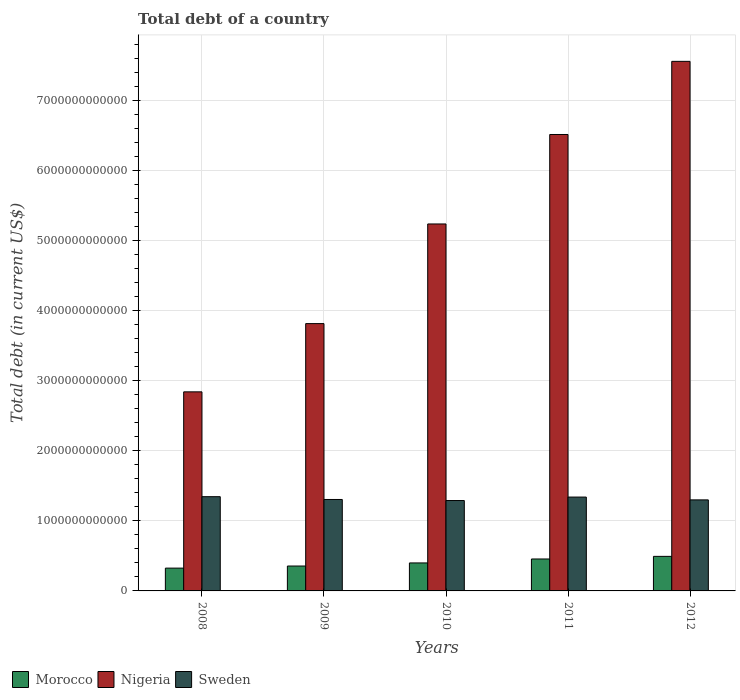How many different coloured bars are there?
Keep it short and to the point. 3. Are the number of bars per tick equal to the number of legend labels?
Provide a short and direct response. Yes. Are the number of bars on each tick of the X-axis equal?
Keep it short and to the point. Yes. In how many cases, is the number of bars for a given year not equal to the number of legend labels?
Keep it short and to the point. 0. What is the debt in Sweden in 2008?
Your answer should be very brief. 1.35e+12. Across all years, what is the maximum debt in Nigeria?
Keep it short and to the point. 7.56e+12. Across all years, what is the minimum debt in Sweden?
Give a very brief answer. 1.29e+12. In which year was the debt in Morocco minimum?
Ensure brevity in your answer.  2008. What is the total debt in Nigeria in the graph?
Offer a terse response. 2.60e+13. What is the difference between the debt in Sweden in 2008 and that in 2012?
Provide a succinct answer. 4.57e+1. What is the difference between the debt in Nigeria in 2008 and the debt in Morocco in 2009?
Provide a succinct answer. 2.49e+12. What is the average debt in Sweden per year?
Your response must be concise. 1.32e+12. In the year 2012, what is the difference between the debt in Morocco and debt in Nigeria?
Offer a terse response. -7.07e+12. What is the ratio of the debt in Nigeria in 2009 to that in 2010?
Your response must be concise. 0.73. Is the debt in Nigeria in 2008 less than that in 2011?
Give a very brief answer. Yes. Is the difference between the debt in Morocco in 2009 and 2012 greater than the difference between the debt in Nigeria in 2009 and 2012?
Give a very brief answer. Yes. What is the difference between the highest and the second highest debt in Morocco?
Keep it short and to the point. 3.75e+1. What is the difference between the highest and the lowest debt in Nigeria?
Offer a very short reply. 4.72e+12. What does the 2nd bar from the left in 2012 represents?
Your answer should be very brief. Nigeria. What does the 3rd bar from the right in 2012 represents?
Provide a succinct answer. Morocco. How many bars are there?
Provide a short and direct response. 15. Are all the bars in the graph horizontal?
Offer a terse response. No. How many years are there in the graph?
Provide a succinct answer. 5. What is the difference between two consecutive major ticks on the Y-axis?
Provide a succinct answer. 1.00e+12. Are the values on the major ticks of Y-axis written in scientific E-notation?
Provide a short and direct response. No. Does the graph contain grids?
Keep it short and to the point. Yes. How many legend labels are there?
Your answer should be compact. 3. How are the legend labels stacked?
Your response must be concise. Horizontal. What is the title of the graph?
Your response must be concise. Total debt of a country. Does "Zambia" appear as one of the legend labels in the graph?
Give a very brief answer. No. What is the label or title of the X-axis?
Offer a very short reply. Years. What is the label or title of the Y-axis?
Give a very brief answer. Total debt (in current US$). What is the Total debt (in current US$) in Morocco in 2008?
Your answer should be compact. 3.26e+11. What is the Total debt (in current US$) in Nigeria in 2008?
Ensure brevity in your answer.  2.84e+12. What is the Total debt (in current US$) of Sweden in 2008?
Keep it short and to the point. 1.35e+12. What is the Total debt (in current US$) in Morocco in 2009?
Offer a very short reply. 3.56e+11. What is the Total debt (in current US$) of Nigeria in 2009?
Your response must be concise. 3.82e+12. What is the Total debt (in current US$) of Sweden in 2009?
Your response must be concise. 1.31e+12. What is the Total debt (in current US$) of Morocco in 2010?
Your response must be concise. 4.00e+11. What is the Total debt (in current US$) of Nigeria in 2010?
Make the answer very short. 5.24e+12. What is the Total debt (in current US$) of Sweden in 2010?
Provide a short and direct response. 1.29e+12. What is the Total debt (in current US$) in Morocco in 2011?
Provide a succinct answer. 4.56e+11. What is the Total debt (in current US$) of Nigeria in 2011?
Your answer should be compact. 6.52e+12. What is the Total debt (in current US$) of Sweden in 2011?
Keep it short and to the point. 1.34e+12. What is the Total debt (in current US$) in Morocco in 2012?
Your answer should be compact. 4.94e+11. What is the Total debt (in current US$) in Nigeria in 2012?
Ensure brevity in your answer.  7.56e+12. What is the Total debt (in current US$) in Sweden in 2012?
Ensure brevity in your answer.  1.30e+12. Across all years, what is the maximum Total debt (in current US$) in Morocco?
Keep it short and to the point. 4.94e+11. Across all years, what is the maximum Total debt (in current US$) of Nigeria?
Ensure brevity in your answer.  7.56e+12. Across all years, what is the maximum Total debt (in current US$) in Sweden?
Give a very brief answer. 1.35e+12. Across all years, what is the minimum Total debt (in current US$) in Morocco?
Offer a very short reply. 3.26e+11. Across all years, what is the minimum Total debt (in current US$) in Nigeria?
Provide a short and direct response. 2.84e+12. Across all years, what is the minimum Total debt (in current US$) of Sweden?
Give a very brief answer. 1.29e+12. What is the total Total debt (in current US$) in Morocco in the graph?
Your answer should be very brief. 2.03e+12. What is the total Total debt (in current US$) in Nigeria in the graph?
Provide a succinct answer. 2.60e+13. What is the total Total debt (in current US$) in Sweden in the graph?
Make the answer very short. 6.58e+12. What is the difference between the Total debt (in current US$) of Morocco in 2008 and that in 2009?
Provide a short and direct response. -2.98e+1. What is the difference between the Total debt (in current US$) in Nigeria in 2008 and that in 2009?
Give a very brief answer. -9.75e+11. What is the difference between the Total debt (in current US$) in Sweden in 2008 and that in 2009?
Your response must be concise. 3.99e+1. What is the difference between the Total debt (in current US$) of Morocco in 2008 and that in 2010?
Your answer should be very brief. -7.41e+1. What is the difference between the Total debt (in current US$) in Nigeria in 2008 and that in 2010?
Your answer should be compact. -2.40e+12. What is the difference between the Total debt (in current US$) of Sweden in 2008 and that in 2010?
Offer a terse response. 5.51e+1. What is the difference between the Total debt (in current US$) of Morocco in 2008 and that in 2011?
Provide a short and direct response. -1.30e+11. What is the difference between the Total debt (in current US$) of Nigeria in 2008 and that in 2011?
Your answer should be very brief. -3.68e+12. What is the difference between the Total debt (in current US$) in Sweden in 2008 and that in 2011?
Keep it short and to the point. 5.63e+09. What is the difference between the Total debt (in current US$) in Morocco in 2008 and that in 2012?
Offer a terse response. -1.68e+11. What is the difference between the Total debt (in current US$) in Nigeria in 2008 and that in 2012?
Make the answer very short. -4.72e+12. What is the difference between the Total debt (in current US$) in Sweden in 2008 and that in 2012?
Provide a succinct answer. 4.57e+1. What is the difference between the Total debt (in current US$) in Morocco in 2009 and that in 2010?
Provide a short and direct response. -4.43e+1. What is the difference between the Total debt (in current US$) of Nigeria in 2009 and that in 2010?
Offer a terse response. -1.42e+12. What is the difference between the Total debt (in current US$) of Sweden in 2009 and that in 2010?
Offer a terse response. 1.52e+1. What is the difference between the Total debt (in current US$) in Morocco in 2009 and that in 2011?
Make the answer very short. -1.01e+11. What is the difference between the Total debt (in current US$) in Nigeria in 2009 and that in 2011?
Make the answer very short. -2.70e+12. What is the difference between the Total debt (in current US$) of Sweden in 2009 and that in 2011?
Your response must be concise. -3.42e+1. What is the difference between the Total debt (in current US$) in Morocco in 2009 and that in 2012?
Keep it short and to the point. -1.38e+11. What is the difference between the Total debt (in current US$) in Nigeria in 2009 and that in 2012?
Offer a very short reply. -3.75e+12. What is the difference between the Total debt (in current US$) of Sweden in 2009 and that in 2012?
Keep it short and to the point. 5.87e+09. What is the difference between the Total debt (in current US$) of Morocco in 2010 and that in 2011?
Make the answer very short. -5.63e+1. What is the difference between the Total debt (in current US$) of Nigeria in 2010 and that in 2011?
Provide a short and direct response. -1.28e+12. What is the difference between the Total debt (in current US$) in Sweden in 2010 and that in 2011?
Ensure brevity in your answer.  -4.94e+1. What is the difference between the Total debt (in current US$) in Morocco in 2010 and that in 2012?
Offer a terse response. -9.38e+1. What is the difference between the Total debt (in current US$) of Nigeria in 2010 and that in 2012?
Your answer should be very brief. -2.32e+12. What is the difference between the Total debt (in current US$) of Sweden in 2010 and that in 2012?
Your response must be concise. -9.33e+09. What is the difference between the Total debt (in current US$) in Morocco in 2011 and that in 2012?
Your answer should be very brief. -3.75e+1. What is the difference between the Total debt (in current US$) in Nigeria in 2011 and that in 2012?
Provide a short and direct response. -1.04e+12. What is the difference between the Total debt (in current US$) of Sweden in 2011 and that in 2012?
Your response must be concise. 4.01e+1. What is the difference between the Total debt (in current US$) of Morocco in 2008 and the Total debt (in current US$) of Nigeria in 2009?
Keep it short and to the point. -3.49e+12. What is the difference between the Total debt (in current US$) in Morocco in 2008 and the Total debt (in current US$) in Sweden in 2009?
Your answer should be compact. -9.80e+11. What is the difference between the Total debt (in current US$) of Nigeria in 2008 and the Total debt (in current US$) of Sweden in 2009?
Offer a terse response. 1.54e+12. What is the difference between the Total debt (in current US$) of Morocco in 2008 and the Total debt (in current US$) of Nigeria in 2010?
Give a very brief answer. -4.92e+12. What is the difference between the Total debt (in current US$) of Morocco in 2008 and the Total debt (in current US$) of Sweden in 2010?
Your answer should be very brief. -9.65e+11. What is the difference between the Total debt (in current US$) in Nigeria in 2008 and the Total debt (in current US$) in Sweden in 2010?
Your response must be concise. 1.55e+12. What is the difference between the Total debt (in current US$) of Morocco in 2008 and the Total debt (in current US$) of Nigeria in 2011?
Make the answer very short. -6.19e+12. What is the difference between the Total debt (in current US$) in Morocco in 2008 and the Total debt (in current US$) in Sweden in 2011?
Give a very brief answer. -1.01e+12. What is the difference between the Total debt (in current US$) of Nigeria in 2008 and the Total debt (in current US$) of Sweden in 2011?
Make the answer very short. 1.50e+12. What is the difference between the Total debt (in current US$) of Morocco in 2008 and the Total debt (in current US$) of Nigeria in 2012?
Make the answer very short. -7.24e+12. What is the difference between the Total debt (in current US$) in Morocco in 2008 and the Total debt (in current US$) in Sweden in 2012?
Your answer should be compact. -9.75e+11. What is the difference between the Total debt (in current US$) of Nigeria in 2008 and the Total debt (in current US$) of Sweden in 2012?
Offer a terse response. 1.54e+12. What is the difference between the Total debt (in current US$) of Morocco in 2009 and the Total debt (in current US$) of Nigeria in 2010?
Give a very brief answer. -4.89e+12. What is the difference between the Total debt (in current US$) in Morocco in 2009 and the Total debt (in current US$) in Sweden in 2010?
Make the answer very short. -9.35e+11. What is the difference between the Total debt (in current US$) of Nigeria in 2009 and the Total debt (in current US$) of Sweden in 2010?
Your response must be concise. 2.53e+12. What is the difference between the Total debt (in current US$) of Morocco in 2009 and the Total debt (in current US$) of Nigeria in 2011?
Offer a terse response. -6.16e+12. What is the difference between the Total debt (in current US$) of Morocco in 2009 and the Total debt (in current US$) of Sweden in 2011?
Your response must be concise. -9.85e+11. What is the difference between the Total debt (in current US$) of Nigeria in 2009 and the Total debt (in current US$) of Sweden in 2011?
Offer a terse response. 2.48e+12. What is the difference between the Total debt (in current US$) of Morocco in 2009 and the Total debt (in current US$) of Nigeria in 2012?
Your answer should be compact. -7.21e+12. What is the difference between the Total debt (in current US$) of Morocco in 2009 and the Total debt (in current US$) of Sweden in 2012?
Your answer should be very brief. -9.45e+11. What is the difference between the Total debt (in current US$) of Nigeria in 2009 and the Total debt (in current US$) of Sweden in 2012?
Your answer should be compact. 2.52e+12. What is the difference between the Total debt (in current US$) of Morocco in 2010 and the Total debt (in current US$) of Nigeria in 2011?
Your response must be concise. -6.12e+12. What is the difference between the Total debt (in current US$) of Morocco in 2010 and the Total debt (in current US$) of Sweden in 2011?
Your answer should be very brief. -9.41e+11. What is the difference between the Total debt (in current US$) in Nigeria in 2010 and the Total debt (in current US$) in Sweden in 2011?
Offer a terse response. 3.90e+12. What is the difference between the Total debt (in current US$) in Morocco in 2010 and the Total debt (in current US$) in Nigeria in 2012?
Give a very brief answer. -7.16e+12. What is the difference between the Total debt (in current US$) of Morocco in 2010 and the Total debt (in current US$) of Sweden in 2012?
Provide a short and direct response. -9.00e+11. What is the difference between the Total debt (in current US$) in Nigeria in 2010 and the Total debt (in current US$) in Sweden in 2012?
Your answer should be compact. 3.94e+12. What is the difference between the Total debt (in current US$) of Morocco in 2011 and the Total debt (in current US$) of Nigeria in 2012?
Keep it short and to the point. -7.11e+12. What is the difference between the Total debt (in current US$) of Morocco in 2011 and the Total debt (in current US$) of Sweden in 2012?
Provide a short and direct response. -8.44e+11. What is the difference between the Total debt (in current US$) of Nigeria in 2011 and the Total debt (in current US$) of Sweden in 2012?
Provide a short and direct response. 5.22e+12. What is the average Total debt (in current US$) of Morocco per year?
Provide a succinct answer. 4.06e+11. What is the average Total debt (in current US$) of Nigeria per year?
Your answer should be very brief. 5.20e+12. What is the average Total debt (in current US$) of Sweden per year?
Offer a very short reply. 1.32e+12. In the year 2008, what is the difference between the Total debt (in current US$) in Morocco and Total debt (in current US$) in Nigeria?
Offer a terse response. -2.52e+12. In the year 2008, what is the difference between the Total debt (in current US$) in Morocco and Total debt (in current US$) in Sweden?
Offer a very short reply. -1.02e+12. In the year 2008, what is the difference between the Total debt (in current US$) in Nigeria and Total debt (in current US$) in Sweden?
Make the answer very short. 1.50e+12. In the year 2009, what is the difference between the Total debt (in current US$) in Morocco and Total debt (in current US$) in Nigeria?
Provide a succinct answer. -3.46e+12. In the year 2009, what is the difference between the Total debt (in current US$) in Morocco and Total debt (in current US$) in Sweden?
Provide a short and direct response. -9.51e+11. In the year 2009, what is the difference between the Total debt (in current US$) in Nigeria and Total debt (in current US$) in Sweden?
Make the answer very short. 2.51e+12. In the year 2010, what is the difference between the Total debt (in current US$) of Morocco and Total debt (in current US$) of Nigeria?
Give a very brief answer. -4.84e+12. In the year 2010, what is the difference between the Total debt (in current US$) of Morocco and Total debt (in current US$) of Sweden?
Offer a terse response. -8.91e+11. In the year 2010, what is the difference between the Total debt (in current US$) in Nigeria and Total debt (in current US$) in Sweden?
Offer a terse response. 3.95e+12. In the year 2011, what is the difference between the Total debt (in current US$) in Morocco and Total debt (in current US$) in Nigeria?
Provide a short and direct response. -6.06e+12. In the year 2011, what is the difference between the Total debt (in current US$) in Morocco and Total debt (in current US$) in Sweden?
Give a very brief answer. -8.84e+11. In the year 2011, what is the difference between the Total debt (in current US$) in Nigeria and Total debt (in current US$) in Sweden?
Make the answer very short. 5.18e+12. In the year 2012, what is the difference between the Total debt (in current US$) in Morocco and Total debt (in current US$) in Nigeria?
Keep it short and to the point. -7.07e+12. In the year 2012, what is the difference between the Total debt (in current US$) of Morocco and Total debt (in current US$) of Sweden?
Ensure brevity in your answer.  -8.07e+11. In the year 2012, what is the difference between the Total debt (in current US$) of Nigeria and Total debt (in current US$) of Sweden?
Your answer should be compact. 6.26e+12. What is the ratio of the Total debt (in current US$) of Morocco in 2008 to that in 2009?
Make the answer very short. 0.92. What is the ratio of the Total debt (in current US$) in Nigeria in 2008 to that in 2009?
Your answer should be very brief. 0.74. What is the ratio of the Total debt (in current US$) in Sweden in 2008 to that in 2009?
Make the answer very short. 1.03. What is the ratio of the Total debt (in current US$) in Morocco in 2008 to that in 2010?
Ensure brevity in your answer.  0.81. What is the ratio of the Total debt (in current US$) in Nigeria in 2008 to that in 2010?
Keep it short and to the point. 0.54. What is the ratio of the Total debt (in current US$) of Sweden in 2008 to that in 2010?
Make the answer very short. 1.04. What is the ratio of the Total debt (in current US$) of Morocco in 2008 to that in 2011?
Make the answer very short. 0.71. What is the ratio of the Total debt (in current US$) of Nigeria in 2008 to that in 2011?
Your answer should be very brief. 0.44. What is the ratio of the Total debt (in current US$) in Morocco in 2008 to that in 2012?
Provide a succinct answer. 0.66. What is the ratio of the Total debt (in current US$) of Nigeria in 2008 to that in 2012?
Offer a terse response. 0.38. What is the ratio of the Total debt (in current US$) in Sweden in 2008 to that in 2012?
Keep it short and to the point. 1.04. What is the ratio of the Total debt (in current US$) in Morocco in 2009 to that in 2010?
Offer a terse response. 0.89. What is the ratio of the Total debt (in current US$) in Nigeria in 2009 to that in 2010?
Offer a terse response. 0.73. What is the ratio of the Total debt (in current US$) in Sweden in 2009 to that in 2010?
Give a very brief answer. 1.01. What is the ratio of the Total debt (in current US$) of Morocco in 2009 to that in 2011?
Your response must be concise. 0.78. What is the ratio of the Total debt (in current US$) of Nigeria in 2009 to that in 2011?
Your answer should be very brief. 0.59. What is the ratio of the Total debt (in current US$) in Sweden in 2009 to that in 2011?
Provide a short and direct response. 0.97. What is the ratio of the Total debt (in current US$) of Morocco in 2009 to that in 2012?
Your response must be concise. 0.72. What is the ratio of the Total debt (in current US$) in Nigeria in 2009 to that in 2012?
Your answer should be very brief. 0.5. What is the ratio of the Total debt (in current US$) of Sweden in 2009 to that in 2012?
Give a very brief answer. 1. What is the ratio of the Total debt (in current US$) of Morocco in 2010 to that in 2011?
Ensure brevity in your answer.  0.88. What is the ratio of the Total debt (in current US$) of Nigeria in 2010 to that in 2011?
Give a very brief answer. 0.8. What is the ratio of the Total debt (in current US$) of Sweden in 2010 to that in 2011?
Provide a succinct answer. 0.96. What is the ratio of the Total debt (in current US$) in Morocco in 2010 to that in 2012?
Provide a short and direct response. 0.81. What is the ratio of the Total debt (in current US$) of Nigeria in 2010 to that in 2012?
Make the answer very short. 0.69. What is the ratio of the Total debt (in current US$) in Morocco in 2011 to that in 2012?
Offer a terse response. 0.92. What is the ratio of the Total debt (in current US$) in Nigeria in 2011 to that in 2012?
Provide a succinct answer. 0.86. What is the ratio of the Total debt (in current US$) of Sweden in 2011 to that in 2012?
Provide a succinct answer. 1.03. What is the difference between the highest and the second highest Total debt (in current US$) of Morocco?
Ensure brevity in your answer.  3.75e+1. What is the difference between the highest and the second highest Total debt (in current US$) of Nigeria?
Offer a terse response. 1.04e+12. What is the difference between the highest and the second highest Total debt (in current US$) of Sweden?
Provide a short and direct response. 5.63e+09. What is the difference between the highest and the lowest Total debt (in current US$) in Morocco?
Make the answer very short. 1.68e+11. What is the difference between the highest and the lowest Total debt (in current US$) in Nigeria?
Give a very brief answer. 4.72e+12. What is the difference between the highest and the lowest Total debt (in current US$) of Sweden?
Give a very brief answer. 5.51e+1. 